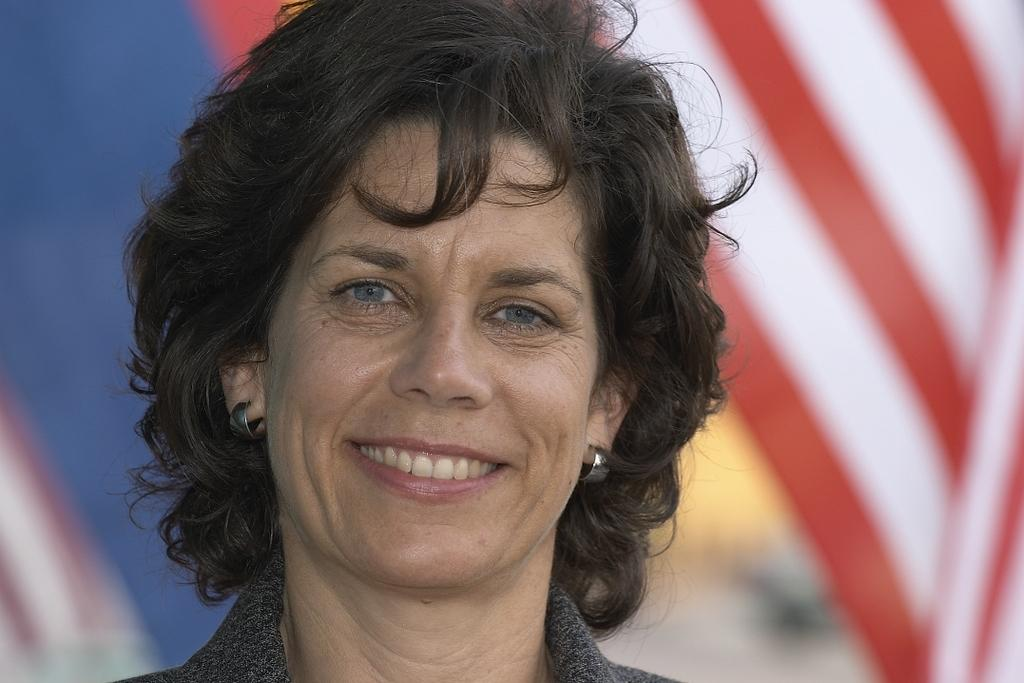Who is present in the image? There is a woman in the image. What is the woman's facial expression? The woman is smiling. What can be seen in the background of the image? There is a flag in the background of the image. How would you describe the background of the image? The background of the image is blurred. What time of day does the woman take care of the afternoon in the image? The image does not show the woman taking care of the afternoon or any specific time of day. 